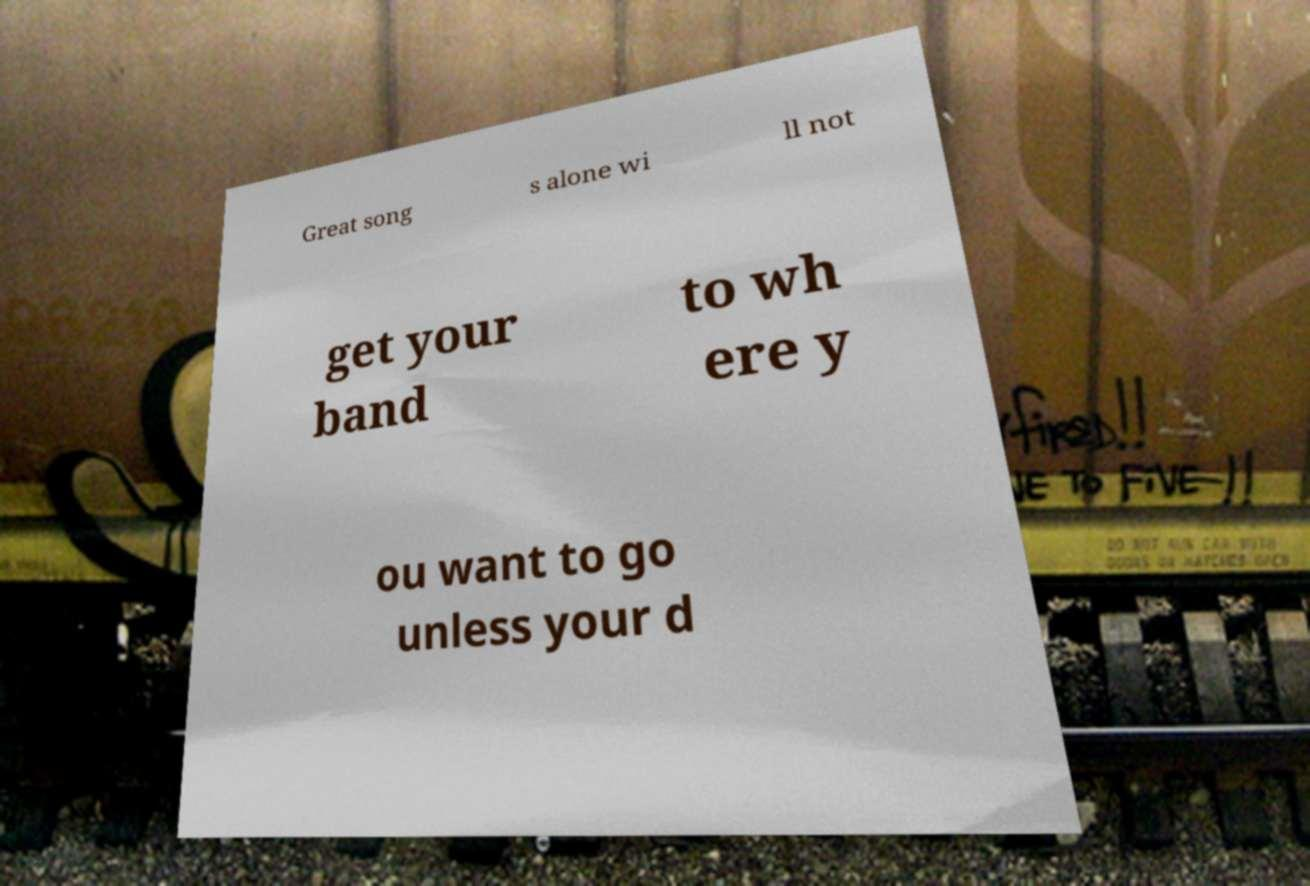For documentation purposes, I need the text within this image transcribed. Could you provide that? Great song s alone wi ll not get your band to wh ere y ou want to go unless your d 